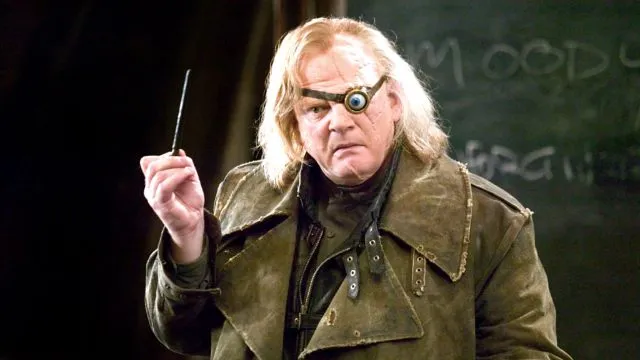Create a whimsical scenario involving the character. In a surprising twist of events, imagine Mad-Eye Moody finding himself in a whimsical wizarding carnival. Clad in his usual battle-worn attire, he begrudgingly participates in a magical game of 'Find the Niffler,' where mischievous, treasure-seeking creatures dart about, hiding shiny objects. Despite his stern demeanor, a twinkle of amusement flickers in his magical eye as he expertly tracks down these elusive creatures, revealing a side of him rarely seen. The carnival atmosphere contrasts starkly with his usual serious persona, creating a delightful and unexpected scenario where even the most vigilant Auror finds a moment of whimsy. 